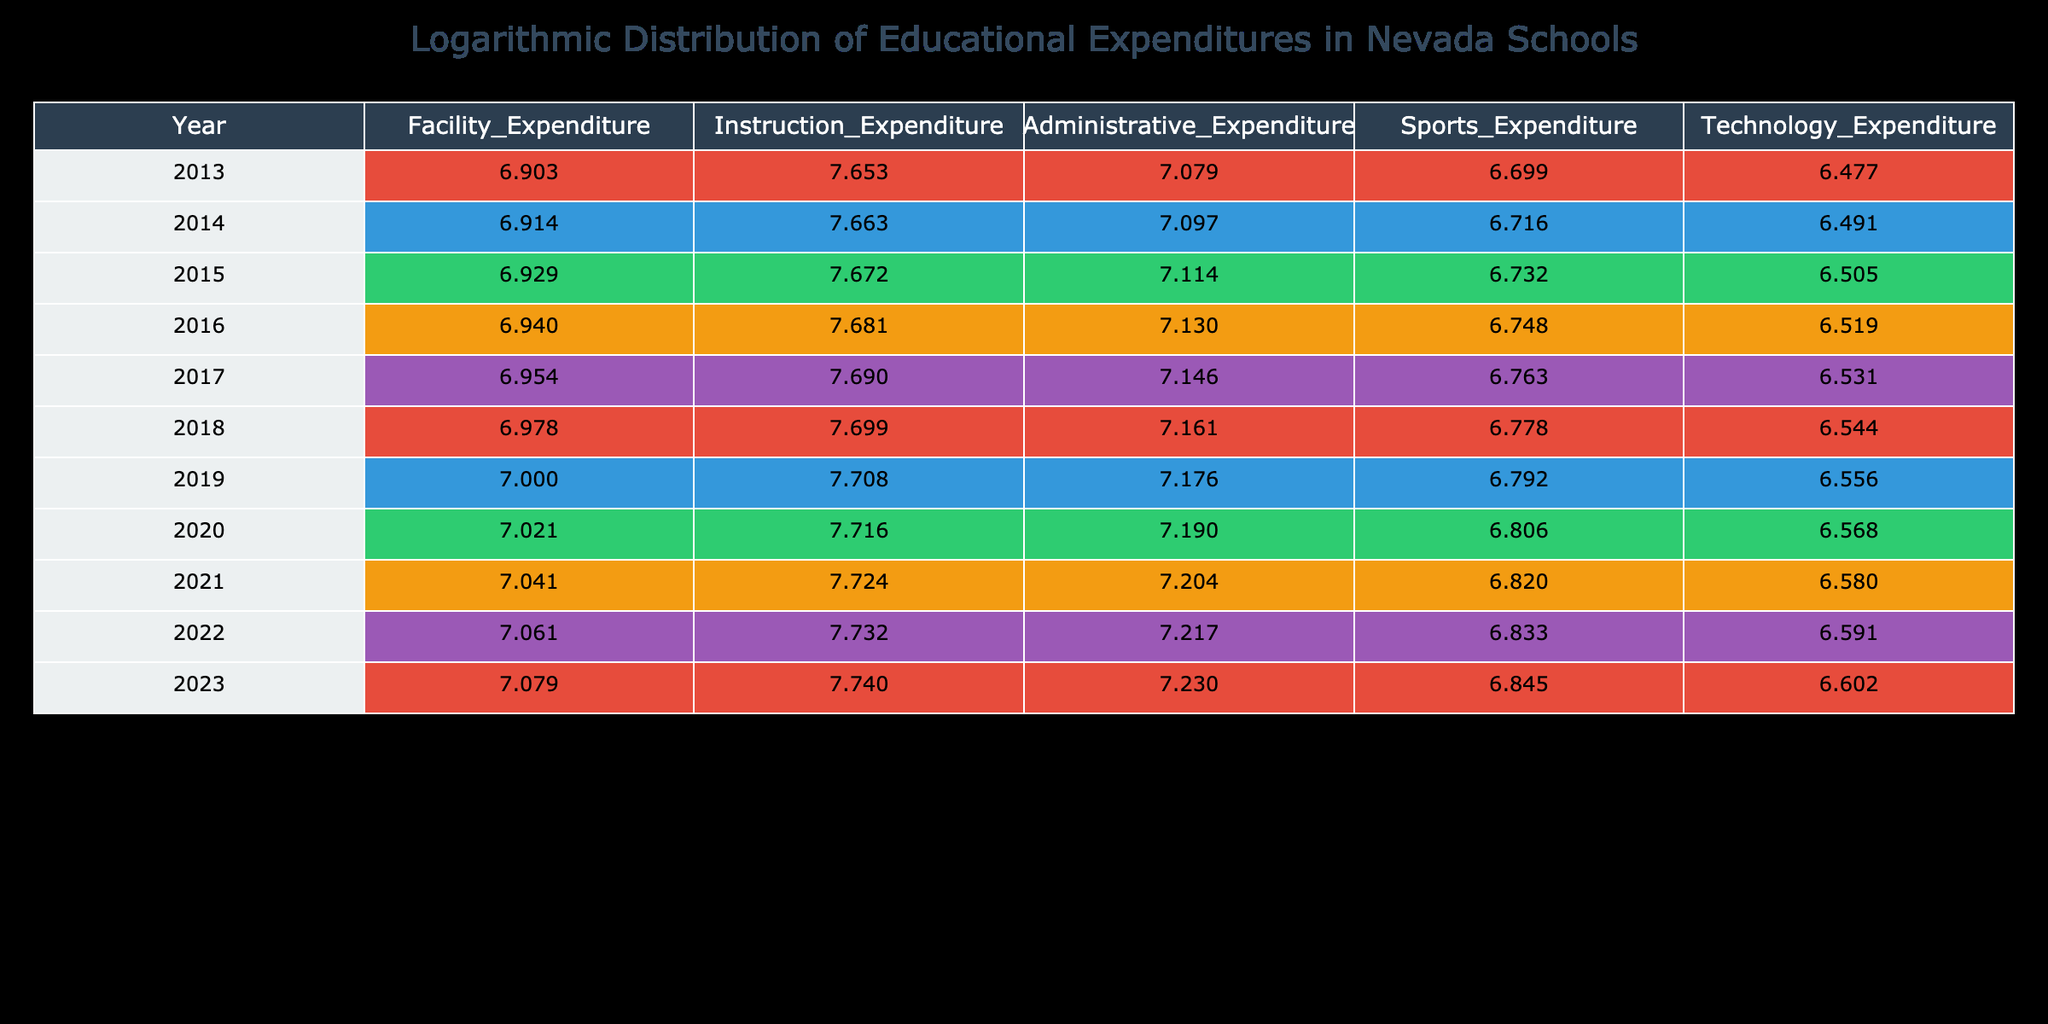What was the total expenditure on sports in 2019? The data in the table indicates that the sports expenditure for the year 2019 is 6200000.
Answer: 6200000 What was the increase in instructional expenditure from 2013 to 2023? The instructional expenditure was 45000000 in 2013 and 55000000 in 2023. The increase is 55000000 - 45000000 = 10000000.
Answer: 10000000 Was the administrative expenditure higher in 2022 than in 2021? The administrative expenditure was 16500000 in 2022 and 16000000 in 2021. Since 16500000 is greater than 16000000, the statement is true.
Answer: Yes What is the average technology expenditure over the decade from 2013 to 2022? To find the average, sum the technology expenditures from each year (3000000 + 3100000 + 3200000 + 3300000 + 3400000 + 3500000 + 3600000 + 3700000 + 3800000 + 3900000) = 34500000, then divide by the number of years (10), so the average is 34500000 / 10 = 3450000.
Answer: 3450000 What was the year with the highest facility expenditure and what was the amount? The highest facility expenditure recorded in the table was 12000000, which occurred in the year 2023.
Answer: 2023, 12000000 What was the percentage increase in facility expenditure from 2013 to 2023? The facility expenditure increased from 8000000 in 2013 to 12000000 in 2023. The increase is 12000000 - 8000000 = 4000000. The percentage increase is (4000000 / 8000000) * 100 = 50%.
Answer: 50% Is the administrative expenditure linear from year to year? Looking at the data, the administrative expenditures are consistent in their increase each year. Hence, it can be considered as linear in terms of their change over the ten years.
Answer: Yes If we exclude the technology expenditure for 2018, what will be the average of the remaining years? The total technology expenditure from 2013 to 2022 excluding 2018 (3000000 + 3100000 + 3200000 + 3300000 + 3400000 + 3600000 + 3700000 + 3800000 + 3900000) = 29500000. Now divided by 9 years gives an average of 29500000 / 9 ≈ 3277777.78.
Answer: 3277777.78 During which year was the total educational expenditure the highest? By adding up each type of expenditure for 2023, the total is 12000000 (Facility) + 55000000 (Instruction) + 17000000 (Administrative) + 7000000 (Sports) + 4000000 (Technology) = 103000000. No other year's total surpasses this.
Answer: 2023 